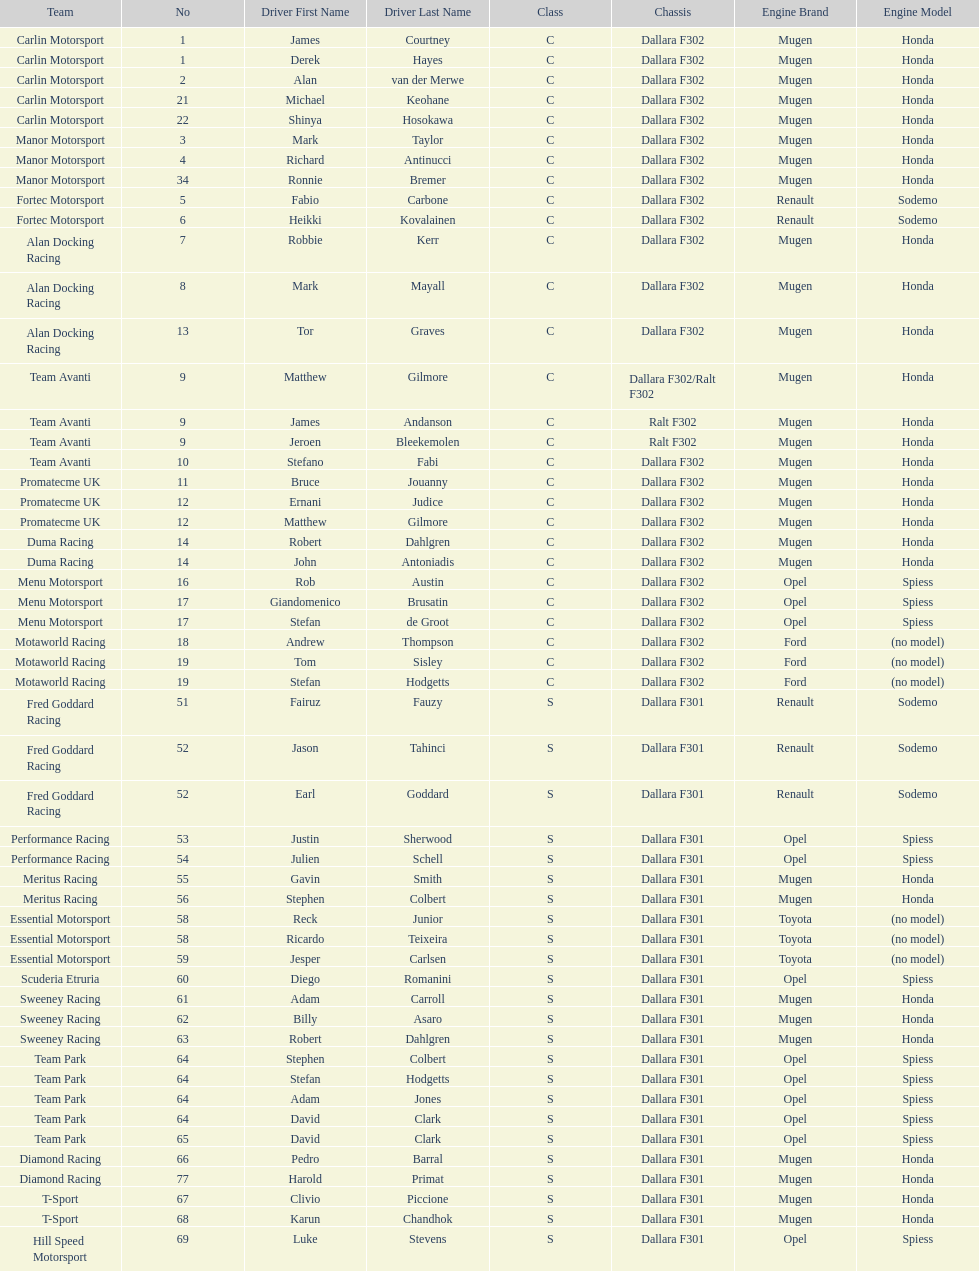What is the number of teams that had drivers all from the same country? 4. 